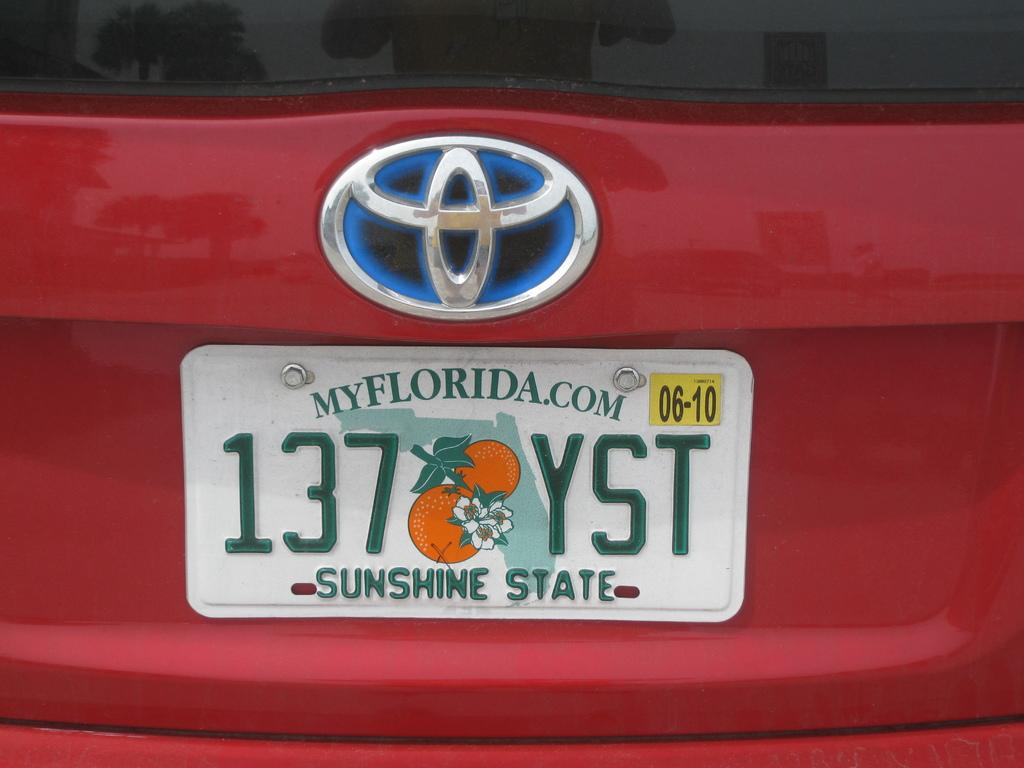<image>
Relay a brief, clear account of the picture shown. The wording on a Florida license plate on the back of a red toyota 